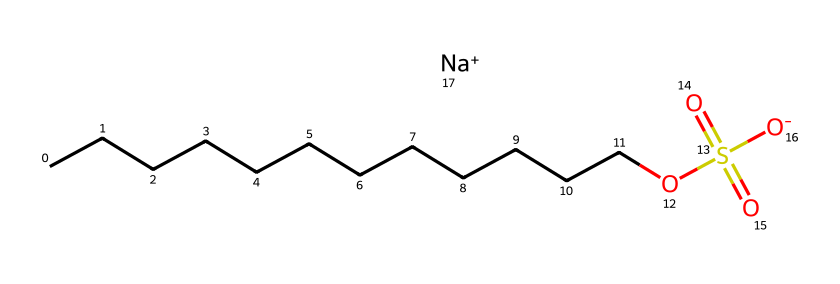What is the main functional group present in this chemical? This chemical contains a sulfonate group, seen from the structure O=S(=O)[O-], which indicates it is a sulfonate.
Answer: sulfonate How many carbon atoms are in the longest chain of the molecule? The chemical has a carbon chain consisting of twelve carbon atoms (CCCCCCCCCCCC), which is the longest continuous chain in the structure.
Answer: twelve What type of ion is associated with this detergent? The structure shows a sodium ion (Na+) at the end of the molecule, which indicates that it is a sodium salt of the sulfonate.
Answer: sodium What characteristic of the molecule suggests it is hypoallergenic? The presence of a long carbon chain and a sulfonate group suggests that it is designed to be less irritating, making it hypoallergenic due to the absence of harsh sulfates or fragrances.
Answer: less irritating What is the overall charge of the molecule? The molecule has a net negative charge due to the sulfonate group ([O-]), while it also contains a sodium cation (+), which balances the overall charge to neutral.
Answer: neutral 